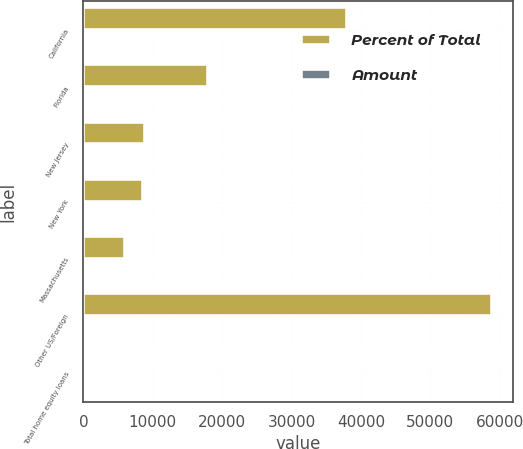<chart> <loc_0><loc_0><loc_500><loc_500><stacked_bar_chart><ecel><fcel>California<fcel>Florida<fcel>New Jersey<fcel>New York<fcel>Massachusetts<fcel>Other US/Foreign<fcel>Total home equity loans<nl><fcel>Percent of Total<fcel>38015<fcel>17893<fcel>8929<fcel>8602<fcel>6008<fcel>58937<fcel>100<nl><fcel>Amount<fcel>27.5<fcel>12.9<fcel>6.5<fcel>6.2<fcel>4.3<fcel>42.6<fcel>100<nl></chart> 